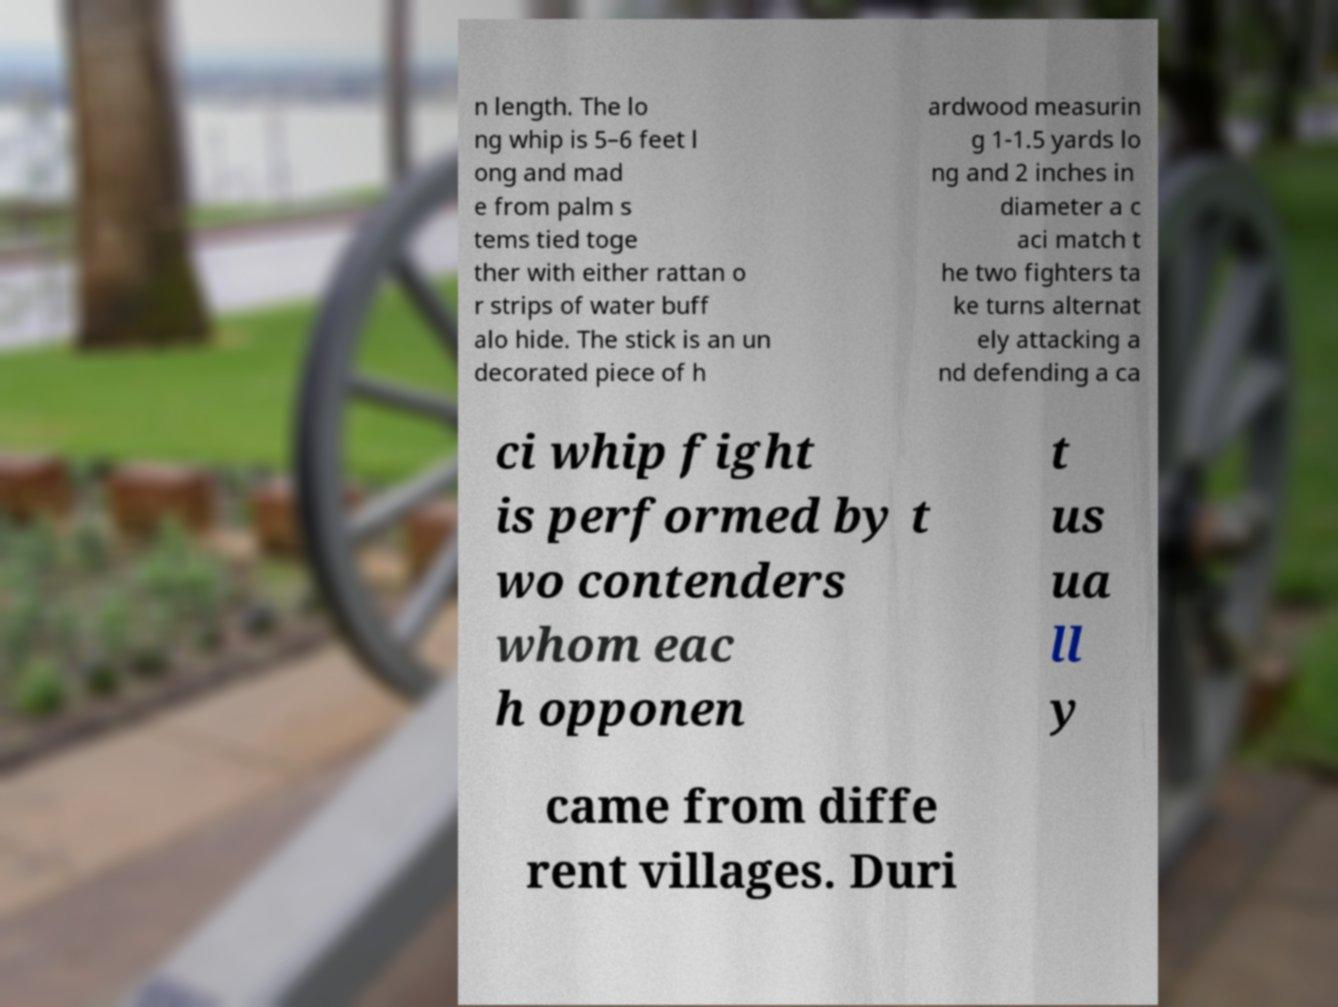Could you assist in decoding the text presented in this image and type it out clearly? n length. The lo ng whip is 5–6 feet l ong and mad e from palm s tems tied toge ther with either rattan o r strips of water buff alo hide. The stick is an un decorated piece of h ardwood measurin g 1-1.5 yards lo ng and 2 inches in diameter a c aci match t he two fighters ta ke turns alternat ely attacking a nd defending a ca ci whip fight is performed by t wo contenders whom eac h opponen t us ua ll y came from diffe rent villages. Duri 